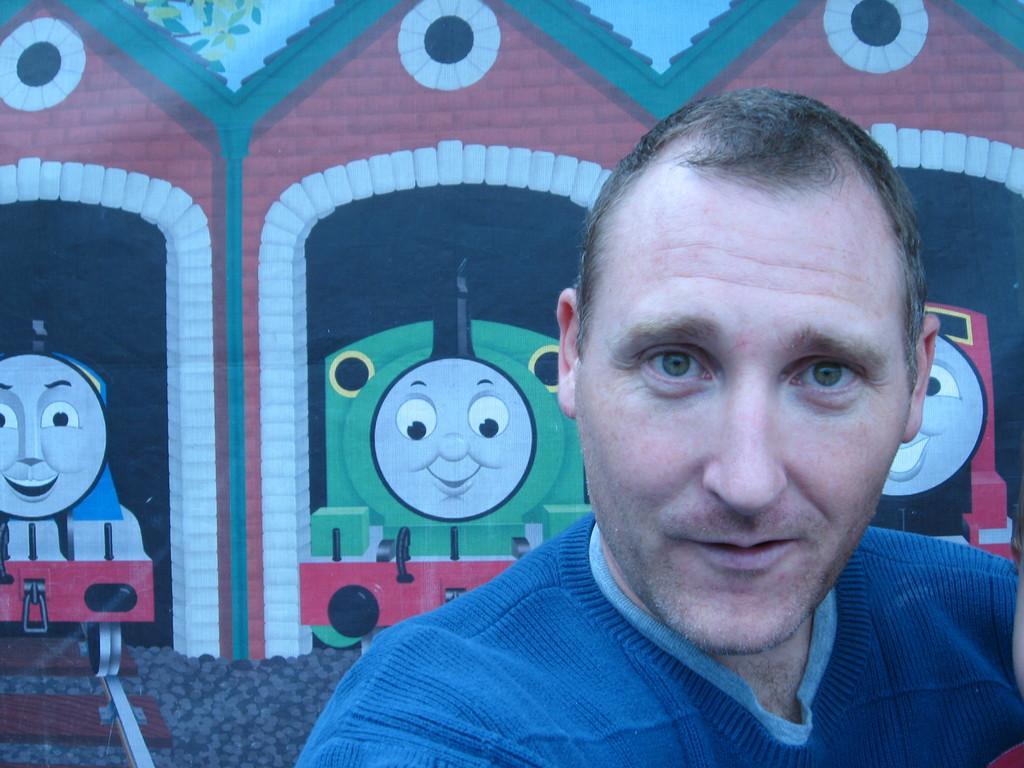Describe this image in one or two sentences. In this image I can see there is an image of a man and there is a wall in the background with a painting of train engines on it. 